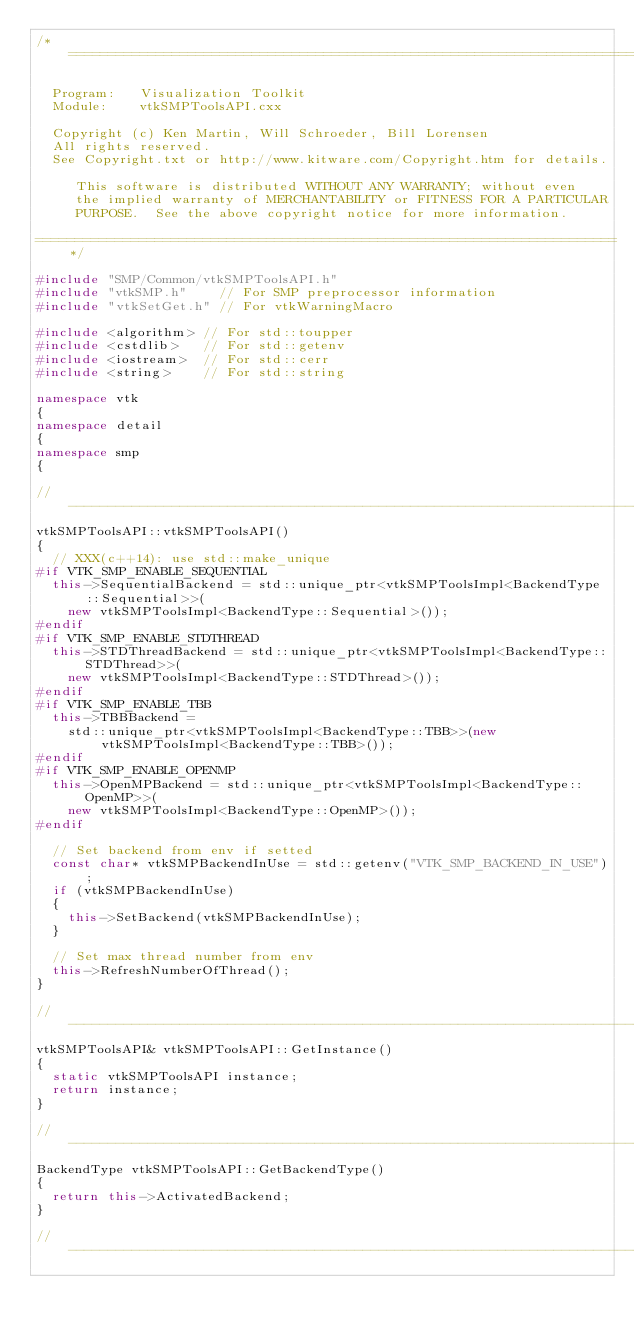Convert code to text. <code><loc_0><loc_0><loc_500><loc_500><_C++_>/*=========================================================================

  Program:   Visualization Toolkit
  Module:    vtkSMPToolsAPI.cxx

  Copyright (c) Ken Martin, Will Schroeder, Bill Lorensen
  All rights reserved.
  See Copyright.txt or http://www.kitware.com/Copyright.htm for details.

     This software is distributed WITHOUT ANY WARRANTY; without even
     the implied warranty of MERCHANTABILITY or FITNESS FOR A PARTICULAR
     PURPOSE.  See the above copyright notice for more information.

=========================================================================*/

#include "SMP/Common/vtkSMPToolsAPI.h"
#include "vtkSMP.h"    // For SMP preprocessor information
#include "vtkSetGet.h" // For vtkWarningMacro

#include <algorithm> // For std::toupper
#include <cstdlib>   // For std::getenv
#include <iostream>  // For std::cerr
#include <string>    // For std::string

namespace vtk
{
namespace detail
{
namespace smp
{

//------------------------------------------------------------------------------
vtkSMPToolsAPI::vtkSMPToolsAPI()
{
  // XXX(c++14): use std::make_unique
#if VTK_SMP_ENABLE_SEQUENTIAL
  this->SequentialBackend = std::unique_ptr<vtkSMPToolsImpl<BackendType::Sequential>>(
    new vtkSMPToolsImpl<BackendType::Sequential>());
#endif
#if VTK_SMP_ENABLE_STDTHREAD
  this->STDThreadBackend = std::unique_ptr<vtkSMPToolsImpl<BackendType::STDThread>>(
    new vtkSMPToolsImpl<BackendType::STDThread>());
#endif
#if VTK_SMP_ENABLE_TBB
  this->TBBBackend =
    std::unique_ptr<vtkSMPToolsImpl<BackendType::TBB>>(new vtkSMPToolsImpl<BackendType::TBB>());
#endif
#if VTK_SMP_ENABLE_OPENMP
  this->OpenMPBackend = std::unique_ptr<vtkSMPToolsImpl<BackendType::OpenMP>>(
    new vtkSMPToolsImpl<BackendType::OpenMP>());
#endif

  // Set backend from env if setted
  const char* vtkSMPBackendInUse = std::getenv("VTK_SMP_BACKEND_IN_USE");
  if (vtkSMPBackendInUse)
  {
    this->SetBackend(vtkSMPBackendInUse);
  }

  // Set max thread number from env
  this->RefreshNumberOfThread();
}

//------------------------------------------------------------------------------
vtkSMPToolsAPI& vtkSMPToolsAPI::GetInstance()
{
  static vtkSMPToolsAPI instance;
  return instance;
}

//------------------------------------------------------------------------------
BackendType vtkSMPToolsAPI::GetBackendType()
{
  return this->ActivatedBackend;
}

//------------------------------------------------------------------------------</code> 